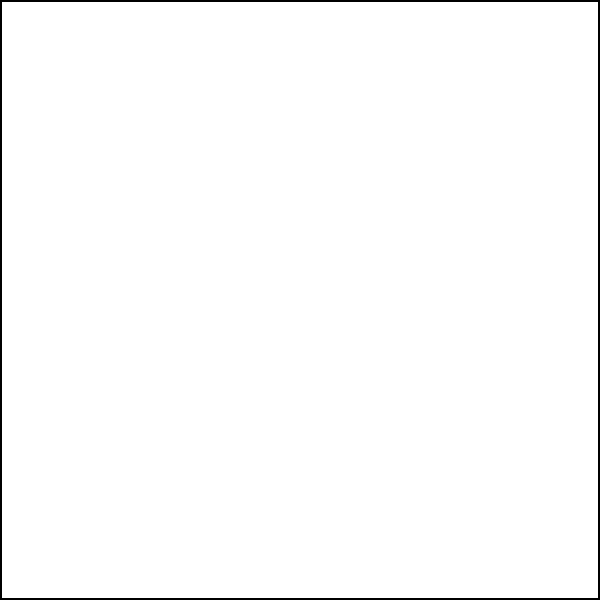In the diagram, a circle is inscribed within a square. If the side length of the square is $s$, express the circumference of the circle in terms of $s$ and $\pi$. How might this relationship between the square and circle reflect the harmony and perfection in God's creation? Let's approach this step-by-step:

1) In an inscribed circle, the diameter of the circle is equal to the side length of the square. Let's call the radius of the circle $r$.

2) The relationship between the side length $s$ and the radius $r$ is:
   $s = 2r$

3) We can express $r$ in terms of $s$:
   $r = \frac{s}{2}$

4) The formula for the circumference of a circle is:
   $C = 2\pi r$

5) Substituting our expression for $r$:
   $C = 2\pi (\frac{s}{2})$

6) Simplifying:
   $C = \pi s$

This elegant relationship, where the circumference of the inscribed circle is simply $\pi$ times the side length of the square, could be seen as a reflection of the divine order in creation. The constant $\pi$, appearing naturally in this geometric relationship, might be viewed as a sign of God's mathematical precision in designing the universe.
Answer: $\pi s$ 